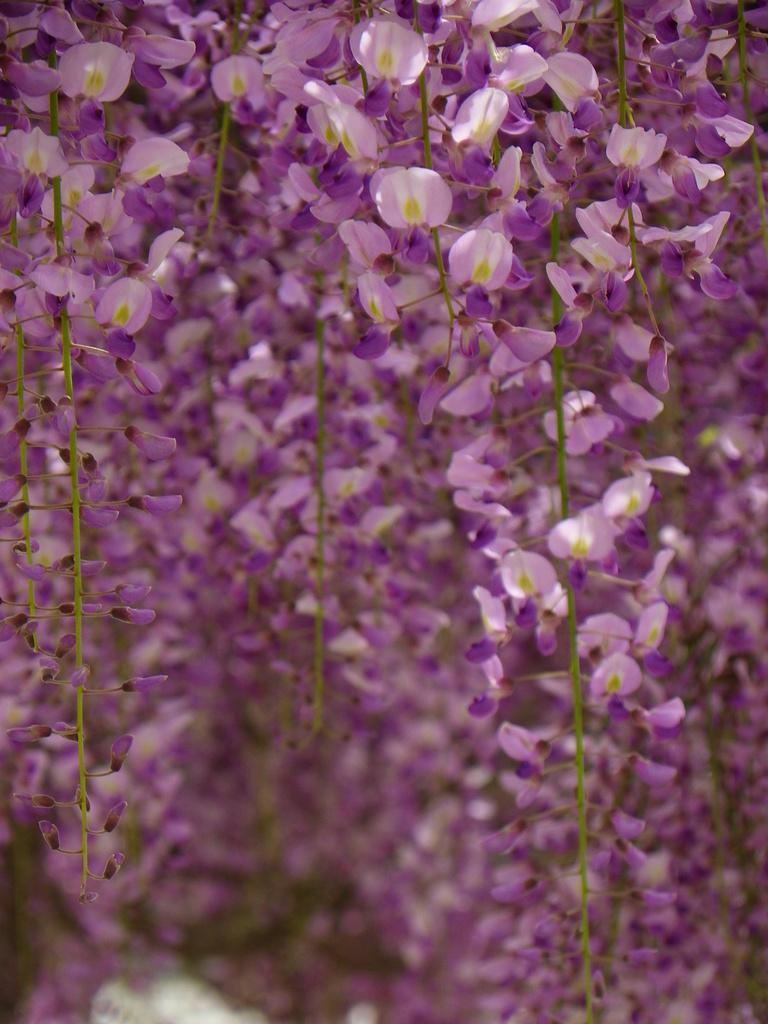What type of flowers are present in the image? There are many violet color flowers in the image. Can you describe any specific features of the flowers? The flowers have stems. What type of industry can be seen operating in the background of the image? There is no industry present in the image; it features many violet color flowers with stems. How many lizards can be seen crawling among the flowers in the image? There are no lizards present in the image; it features many violet color flowers with stems. 